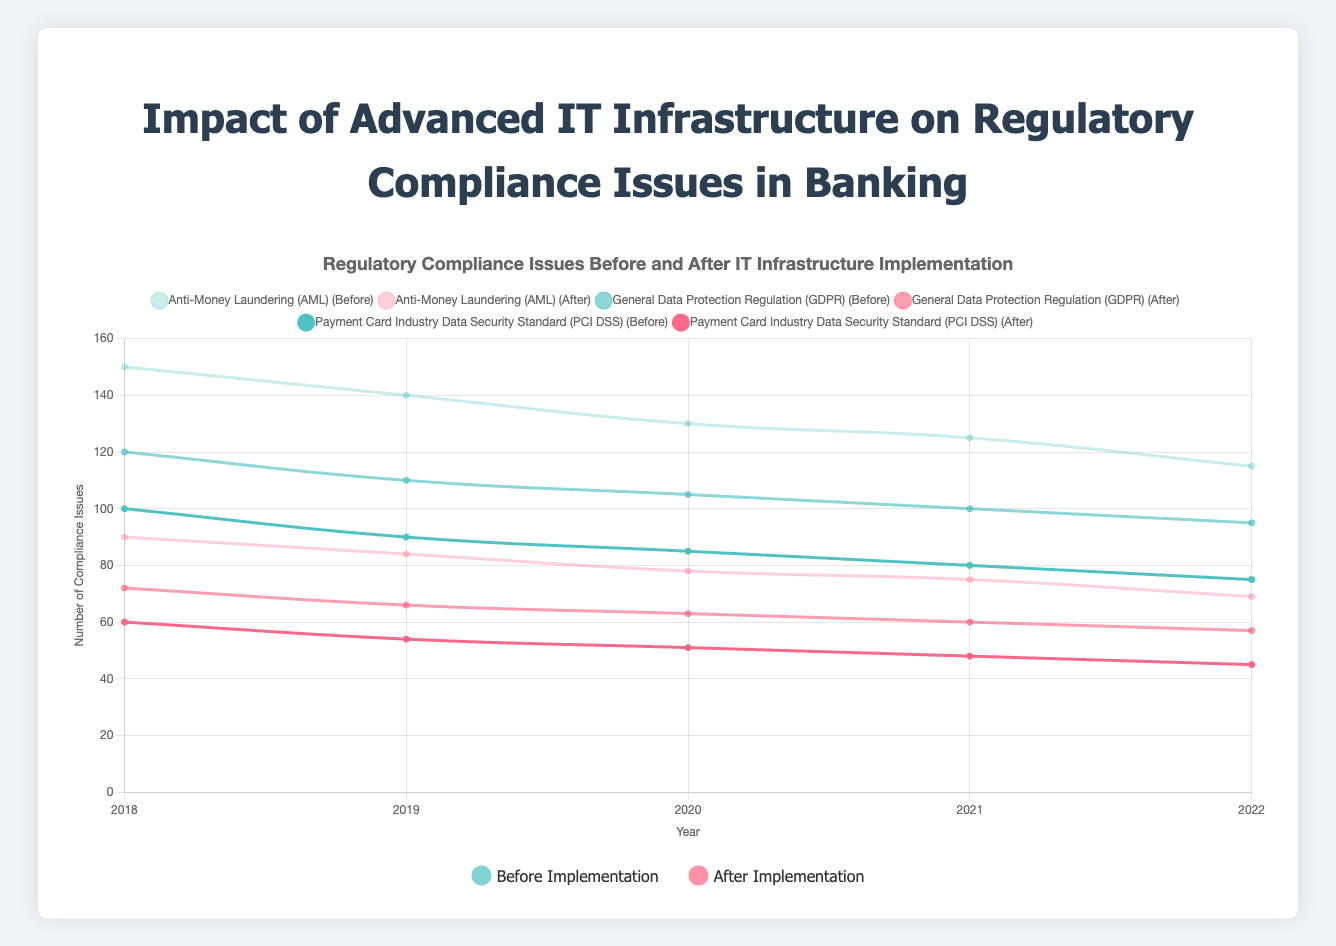What was the reduction in Anti-Money Laundering (AML) compliance issues between 2018 and 2022? The number of AML compliance issues before implementation was 150 in 2018 and reduced to 115 in 2022. After implementation, the issues reduced from 90 in 2018 to 69 in 2022. So, the reduction for before implementation is (150 - 115) = 35 and for after implementation is (90 - 69) = 21.
Answer: 35, 21 Which regulation type showed the largest decrease in compliance issues after implementing advanced IT solutions in 2021? In 2021, the compliance issues for "Anti-Money Laundering (AML)" decreased by (125 - 75) = 50, for "General Data Protection Regulation (GDPR)" decreased by (100 - 60) = 40, and for "Payment Card Industry Data Security Standard (PCI DSS)" decreased by (80 - 48) = 32. Thus, the largest decrease is 50 for AML.
Answer: AML In which year did the General Data Protection Regulation (GDPR) show the smallest number of compliance issues after implementation? Looking at the GDPR after implementation numbers: 2018 - 72, 2019 - 66, 2020 - 63, 2021 - 60, and 2022 - 57. The smallest number is 57 in 2022.
Answer: 2022 How many total compliance issues were there before implementing IT solutions for all three regulations in 2020? Adding up the compliance issues before implementation for 2020: AML (130), GDPR (105), and PCI DSS (85), we get (130 + 105 + 85) = 320.
Answer: 320 Which year had the highest number of Payment Card Industry Data Security Standard (PCI DSS) compliance issues after implementation? For PCI DSS after implementation: 2018 - 60, 2019 - 54, 2020 - 51, 2021 - 48, 2022 - 45. The highest number is 60 in 2018.
Answer: 2018 Did the trend in the number of AML compliance issues before implementation consistently decrease from 2018 to 2022? Observing the AML compliance issues before implementation: 2018 - 150, 2019 - 140, 2020 - 130, 2021 - 125, 2022 - 115, the numbers consistently decrease each year.
Answer: Yes Compare the decrease in compliance issues for GDPR before and after implementation from 2018 to 2021. Which saw a greater decrease? Before implementation for GDPR: 2018 - 120, 2021 - 100, the decrease is (120 - 100) = 20. After implementation: 2018 - 72, 2021 - 60, the decrease is (72 - 60) = 12. Thus, before implementation saw a greater decrease.
Answer: Before implementation What was the average number of PCI DSS compliance issues after implementation across all years? Sum the PCI DSS compliance issues after implementation for all years: 60, 54, 51, 48, 45. The total is (60 + 54 + 51 + 48 + 45) = 258. Divide by the number of years (5), the average is 258 / 5 = 51.6.
Answer: 51.6 Which regulation type had the smallest difference in compliance issues before and after implementation in 2019? In 2019, AML had (140 - 84) = 56, GDPR had (110 - 66) = 44, and PCI DSS had (90 - 54) = 36. The smallest difference is for PCI DSS, 36.
Answer: PCI DSS 